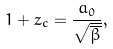Convert formula to latex. <formula><loc_0><loc_0><loc_500><loc_500>1 + z _ { c } = \frac { a _ { 0 } } { \sqrt { \overline { \beta } } } ,</formula> 